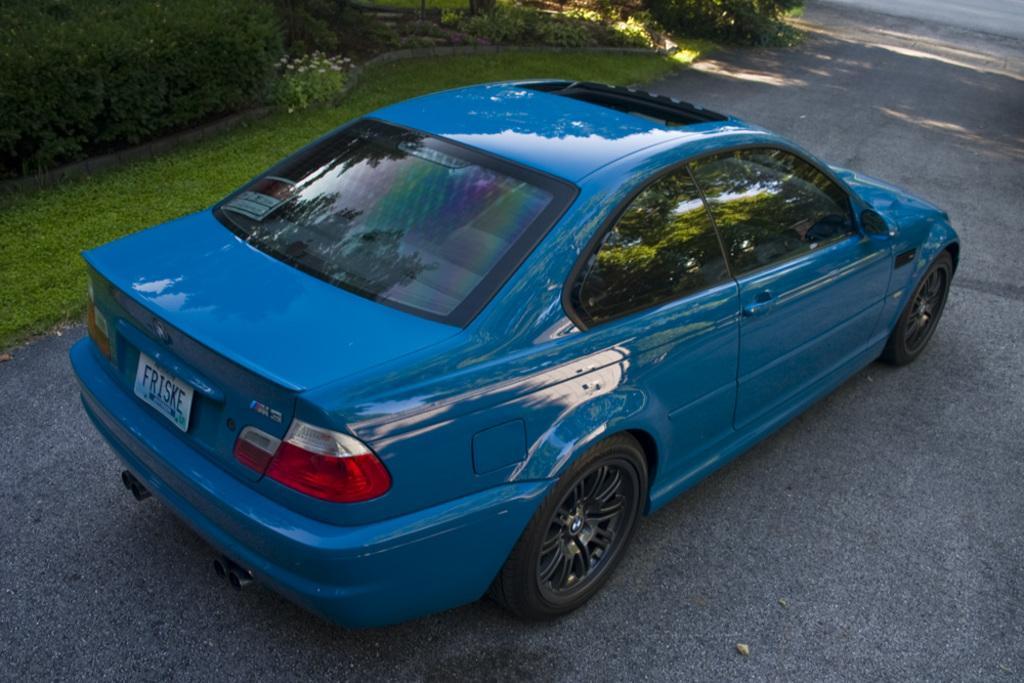Can you describe this image briefly? In this image I can see the road, a car which is blue and black in color on the road, few trees which are green in color, some grass and few flowers which are white in color. 